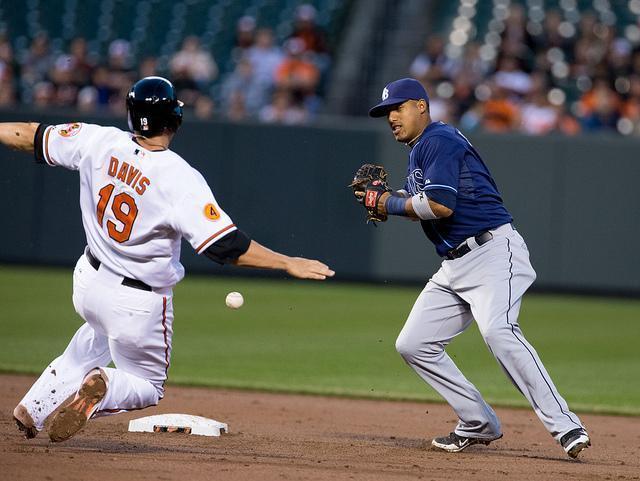What is 19 trying to do?
Pick the right solution, then justify: 'Answer: answer
Rationale: rationale.'
Options: Sleep, touch base, get ball, avoid player. Answer: touch base.
Rationale: He is trying to get to the base before the other player catches the ball 